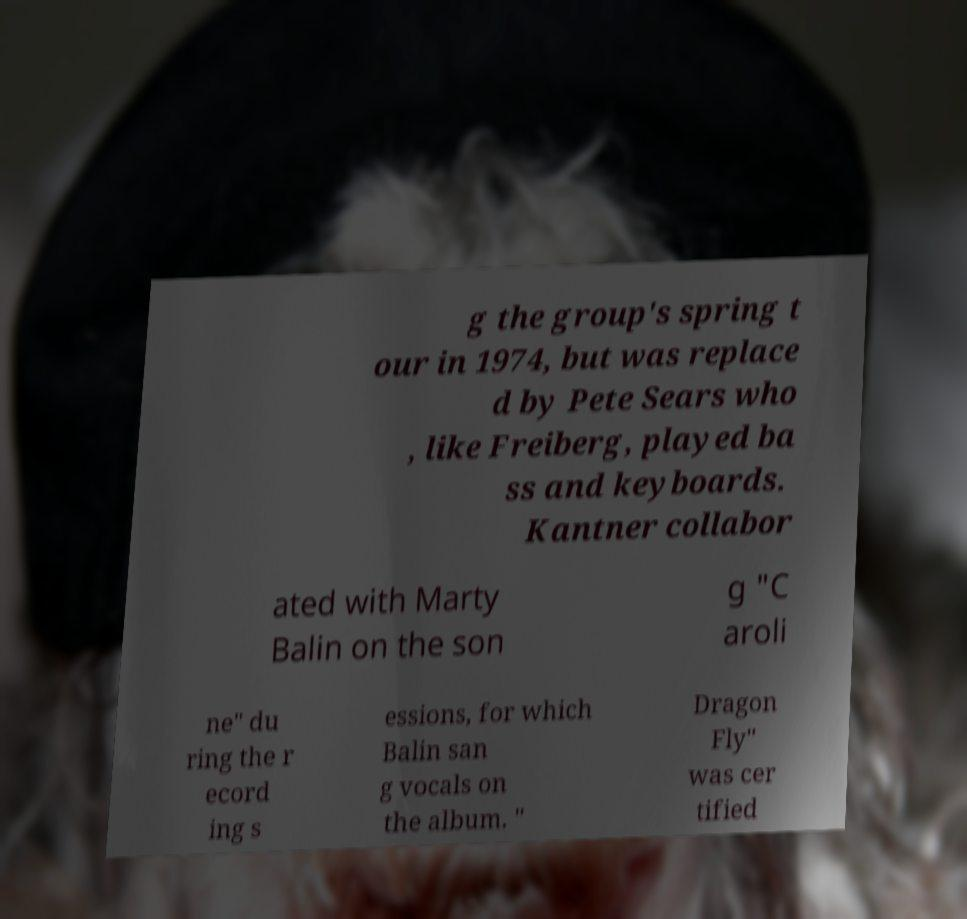What messages or text are displayed in this image? I need them in a readable, typed format. g the group's spring t our in 1974, but was replace d by Pete Sears who , like Freiberg, played ba ss and keyboards. Kantner collabor ated with Marty Balin on the son g "C aroli ne" du ring the r ecord ing s essions, for which Balin san g vocals on the album. " Dragon Fly" was cer tified 